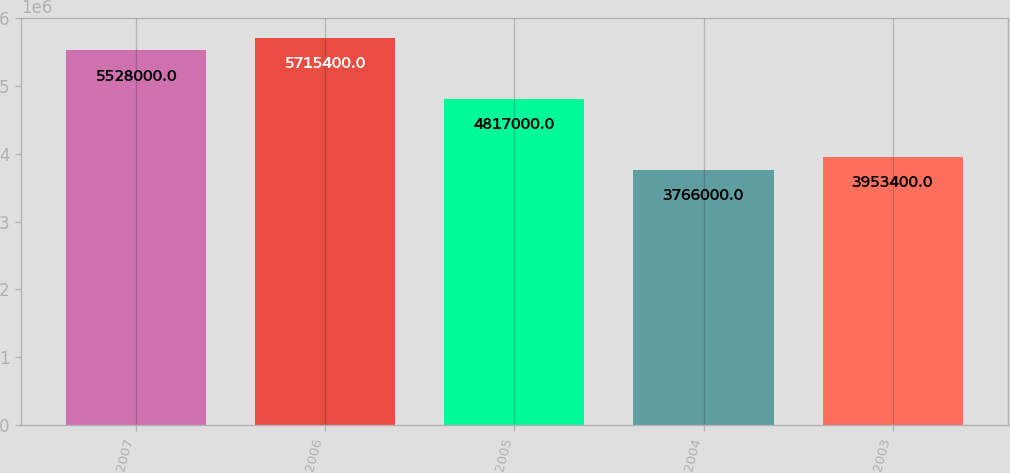Convert chart to OTSL. <chart><loc_0><loc_0><loc_500><loc_500><bar_chart><fcel>2007<fcel>2006<fcel>2005<fcel>2004<fcel>2003<nl><fcel>5.528e+06<fcel>5.7154e+06<fcel>4.817e+06<fcel>3.766e+06<fcel>3.9534e+06<nl></chart> 